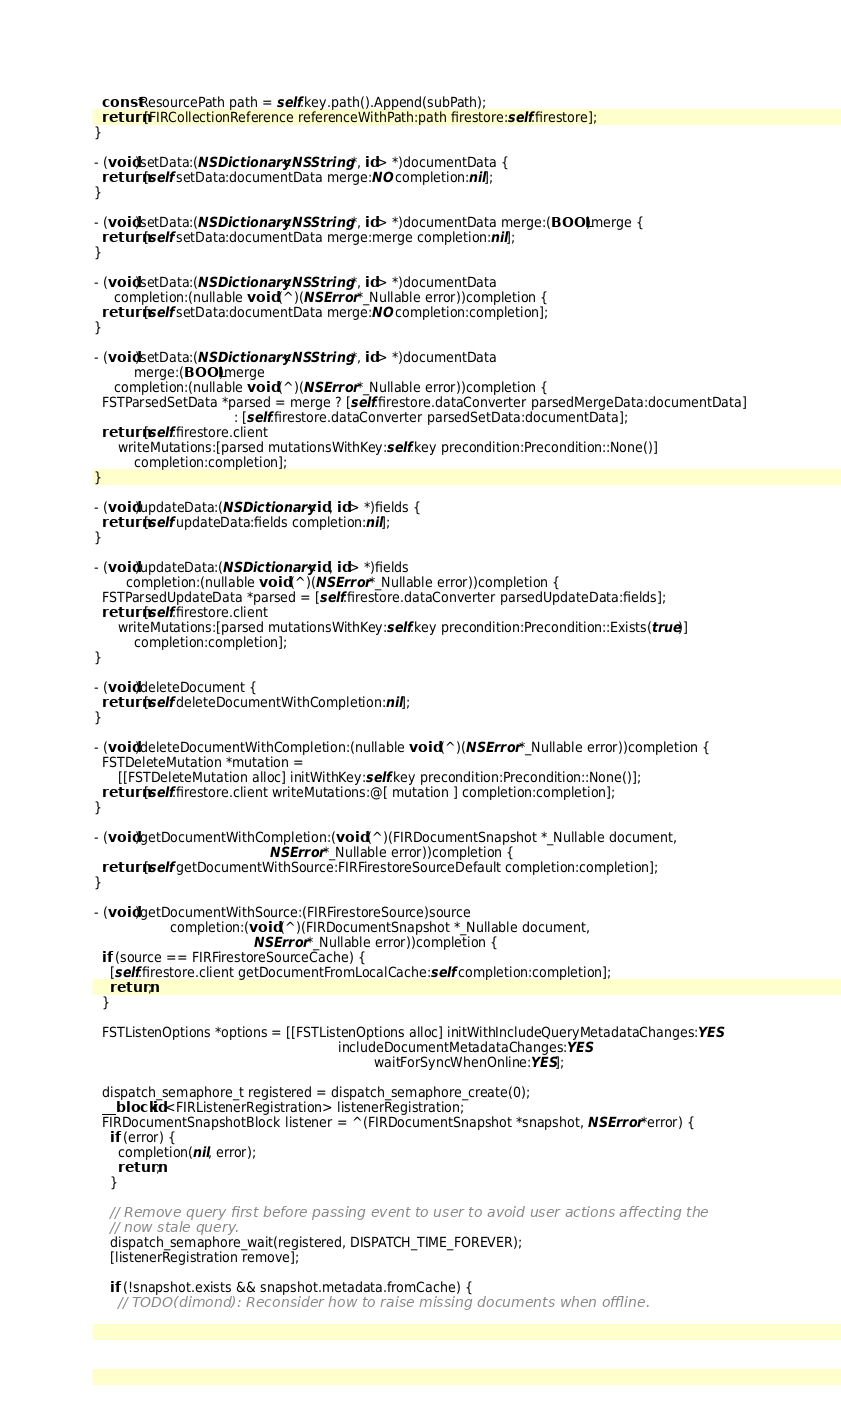<code> <loc_0><loc_0><loc_500><loc_500><_ObjectiveC_>  const ResourcePath path = self.key.path().Append(subPath);
  return [FIRCollectionReference referenceWithPath:path firestore:self.firestore];
}

- (void)setData:(NSDictionary<NSString *, id> *)documentData {
  return [self setData:documentData merge:NO completion:nil];
}

- (void)setData:(NSDictionary<NSString *, id> *)documentData merge:(BOOL)merge {
  return [self setData:documentData merge:merge completion:nil];
}

- (void)setData:(NSDictionary<NSString *, id> *)documentData
     completion:(nullable void (^)(NSError *_Nullable error))completion {
  return [self setData:documentData merge:NO completion:completion];
}

- (void)setData:(NSDictionary<NSString *, id> *)documentData
          merge:(BOOL)merge
     completion:(nullable void (^)(NSError *_Nullable error))completion {
  FSTParsedSetData *parsed = merge ? [self.firestore.dataConverter parsedMergeData:documentData]
                                   : [self.firestore.dataConverter parsedSetData:documentData];
  return [self.firestore.client
      writeMutations:[parsed mutationsWithKey:self.key precondition:Precondition::None()]
          completion:completion];
}

- (void)updateData:(NSDictionary<id, id> *)fields {
  return [self updateData:fields completion:nil];
}

- (void)updateData:(NSDictionary<id, id> *)fields
        completion:(nullable void (^)(NSError *_Nullable error))completion {
  FSTParsedUpdateData *parsed = [self.firestore.dataConverter parsedUpdateData:fields];
  return [self.firestore.client
      writeMutations:[parsed mutationsWithKey:self.key precondition:Precondition::Exists(true)]
          completion:completion];
}

- (void)deleteDocument {
  return [self deleteDocumentWithCompletion:nil];
}

- (void)deleteDocumentWithCompletion:(nullable void (^)(NSError *_Nullable error))completion {
  FSTDeleteMutation *mutation =
      [[FSTDeleteMutation alloc] initWithKey:self.key precondition:Precondition::None()];
  return [self.firestore.client writeMutations:@[ mutation ] completion:completion];
}

- (void)getDocumentWithCompletion:(void (^)(FIRDocumentSnapshot *_Nullable document,
                                            NSError *_Nullable error))completion {
  return [self getDocumentWithSource:FIRFirestoreSourceDefault completion:completion];
}

- (void)getDocumentWithSource:(FIRFirestoreSource)source
                   completion:(void (^)(FIRDocumentSnapshot *_Nullable document,
                                        NSError *_Nullable error))completion {
  if (source == FIRFirestoreSourceCache) {
    [self.firestore.client getDocumentFromLocalCache:self completion:completion];
    return;
  }

  FSTListenOptions *options = [[FSTListenOptions alloc] initWithIncludeQueryMetadataChanges:YES
                                                             includeDocumentMetadataChanges:YES
                                                                      waitForSyncWhenOnline:YES];

  dispatch_semaphore_t registered = dispatch_semaphore_create(0);
  __block id<FIRListenerRegistration> listenerRegistration;
  FIRDocumentSnapshotBlock listener = ^(FIRDocumentSnapshot *snapshot, NSError *error) {
    if (error) {
      completion(nil, error);
      return;
    }

    // Remove query first before passing event to user to avoid user actions affecting the
    // now stale query.
    dispatch_semaphore_wait(registered, DISPATCH_TIME_FOREVER);
    [listenerRegistration remove];

    if (!snapshot.exists && snapshot.metadata.fromCache) {
      // TODO(dimond): Reconsider how to raise missing documents when offline.</code> 